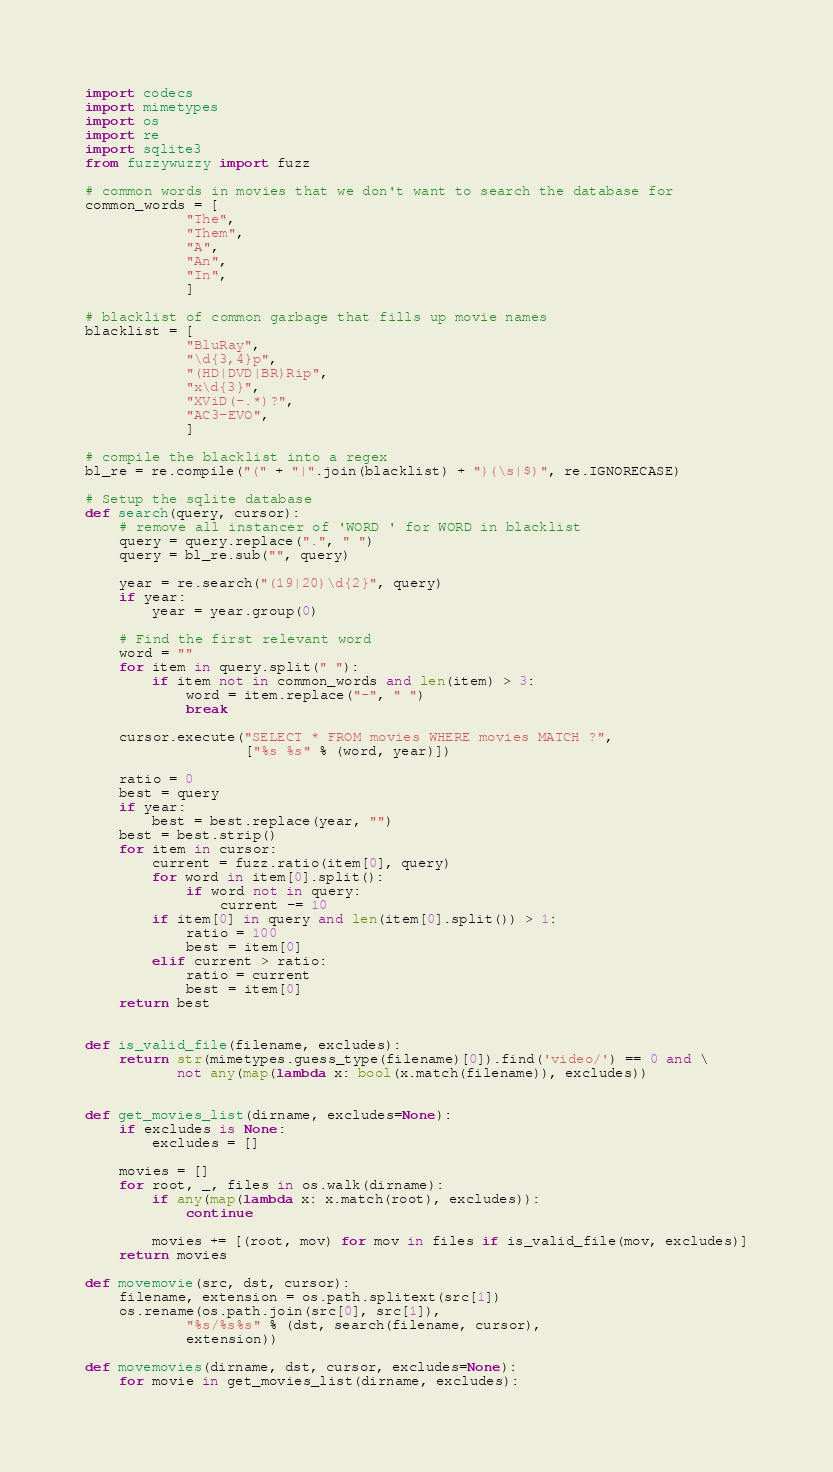<code> <loc_0><loc_0><loc_500><loc_500><_Python_>import codecs
import mimetypes
import os
import re
import sqlite3
from fuzzywuzzy import fuzz

# common words in movies that we don't want to search the database for
common_words = [
            "The",
            "Them",
            "A",
            "An",
            "In",
            ]

# blacklist of common garbage that fills up movie names
blacklist = [
            "BluRay",
            "\d{3,4}p",
            "(HD|DVD|BR)Rip",
            "x\d{3}",
            "XViD(-.*)?",
            "AC3-EVO",
            ]

# compile the blacklist into a regex
bl_re = re.compile("(" + "|".join(blacklist) + ")(\s|$)", re.IGNORECASE)

# Setup the sqlite database
def search(query, cursor):
    # remove all instancer of 'WORD ' for WORD in blacklist
    query = query.replace(".", " ")
    query = bl_re.sub("", query)

    year = re.search("(19|20)\d{2}", query)
    if year:
        year = year.group(0)

    # Find the first relevant word
    word = ""
    for item in query.split(" "):
        if item not in common_words and len(item) > 3:
            word = item.replace("-", " ")
            break

    cursor.execute("SELECT * FROM movies WHERE movies MATCH ?",
                   ["%s %s" % (word, year)])

    ratio = 0
    best = query
    if year:
        best = best.replace(year, "")
    best = best.strip()
    for item in cursor:
        current = fuzz.ratio(item[0], query)
        for word in item[0].split():
            if word not in query:
                current -= 10
        if item[0] in query and len(item[0].split()) > 1:
            ratio = 100
            best = item[0]
        elif current > ratio:
            ratio = current
            best = item[0]
    return best


def is_valid_file(filename, excludes):
    return str(mimetypes.guess_type(filename)[0]).find('video/') == 0 and \
           not any(map(lambda x: bool(x.match(filename)), excludes))


def get_movies_list(dirname, excludes=None):
    if excludes is None:
        excludes = []

    movies = []
    for root, _, files in os.walk(dirname):
        if any(map(lambda x: x.match(root), excludes)):
            continue

        movies += [(root, mov) for mov in files if is_valid_file(mov, excludes)]
    return movies

def movemovie(src, dst, cursor):
    filename, extension = os.path.splitext(src[1])
    os.rename(os.path.join(src[0], src[1]),
            "%s/%s%s" % (dst, search(filename, cursor),
            extension))

def movemovies(dirname, dst, cursor, excludes=None):
    for movie in get_movies_list(dirname, excludes):</code> 